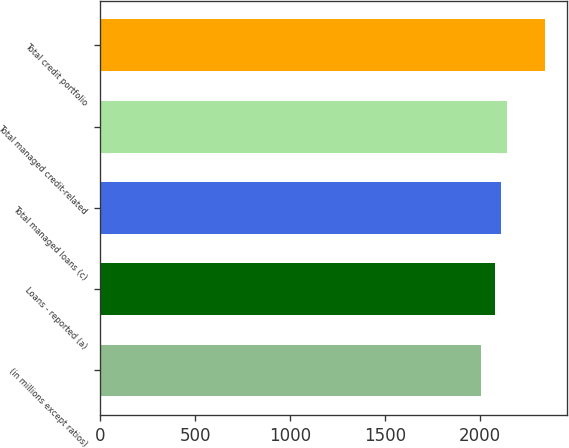Convert chart to OTSL. <chart><loc_0><loc_0><loc_500><loc_500><bar_chart><fcel>(in millions except ratios)<fcel>Loans - reported (a)<fcel>Total managed loans (c)<fcel>Total managed credit-related<fcel>Total credit portfolio<nl><fcel>2006<fcel>2077<fcel>2110.5<fcel>2144<fcel>2341<nl></chart> 